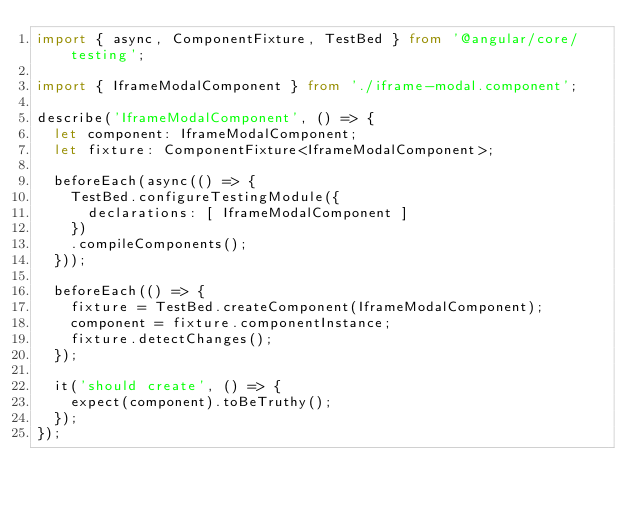<code> <loc_0><loc_0><loc_500><loc_500><_TypeScript_>import { async, ComponentFixture, TestBed } from '@angular/core/testing';

import { IframeModalComponent } from './iframe-modal.component';

describe('IframeModalComponent', () => {
  let component: IframeModalComponent;
  let fixture: ComponentFixture<IframeModalComponent>;

  beforeEach(async(() => {
    TestBed.configureTestingModule({
      declarations: [ IframeModalComponent ]
    })
    .compileComponents();
  }));

  beforeEach(() => {
    fixture = TestBed.createComponent(IframeModalComponent);
    component = fixture.componentInstance;
    fixture.detectChanges();
  });

  it('should create', () => {
    expect(component).toBeTruthy();
  });
});
</code> 